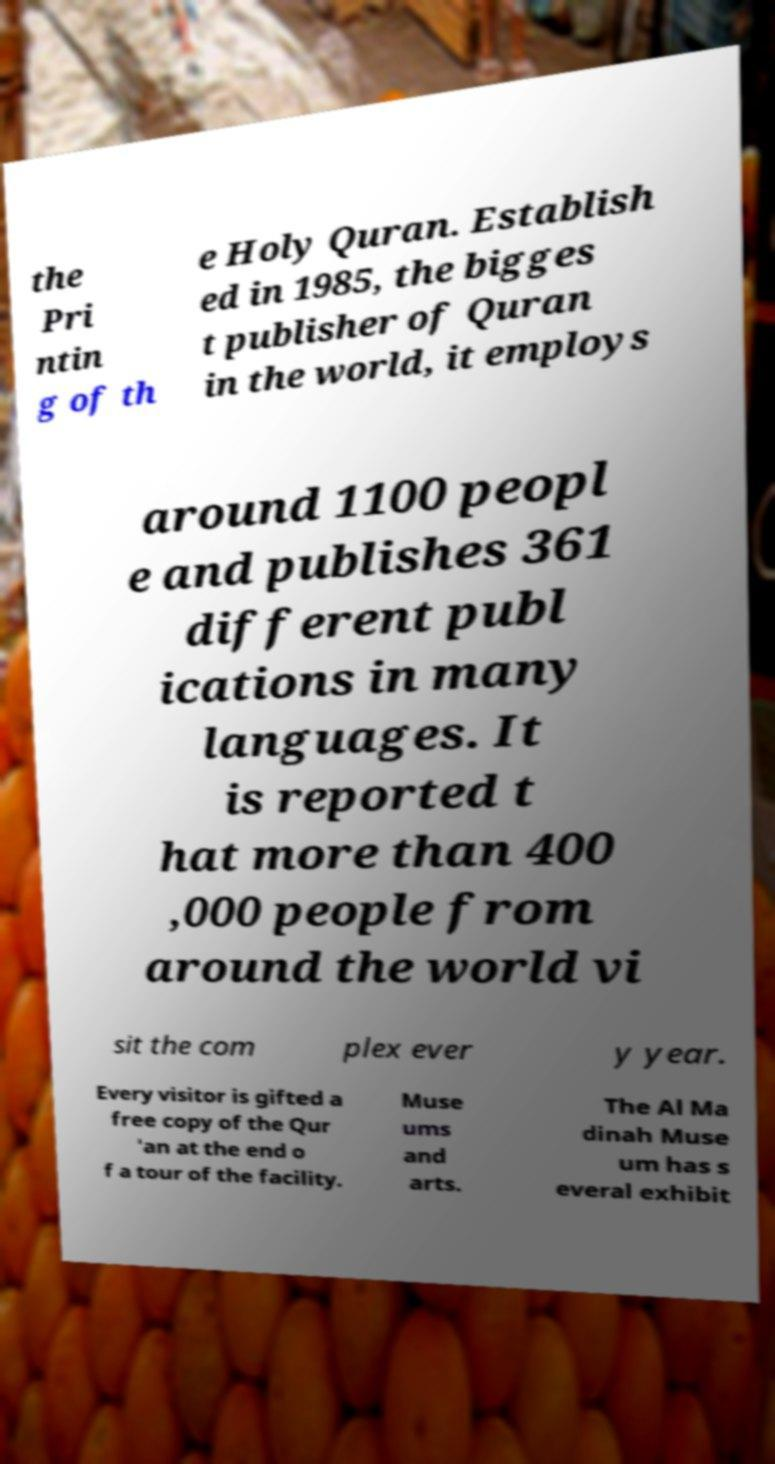There's text embedded in this image that I need extracted. Can you transcribe it verbatim? the Pri ntin g of th e Holy Quran. Establish ed in 1985, the bigges t publisher of Quran in the world, it employs around 1100 peopl e and publishes 361 different publ ications in many languages. It is reported t hat more than 400 ,000 people from around the world vi sit the com plex ever y year. Every visitor is gifted a free copy of the Qur 'an at the end o f a tour of the facility. Muse ums and arts. The Al Ma dinah Muse um has s everal exhibit 